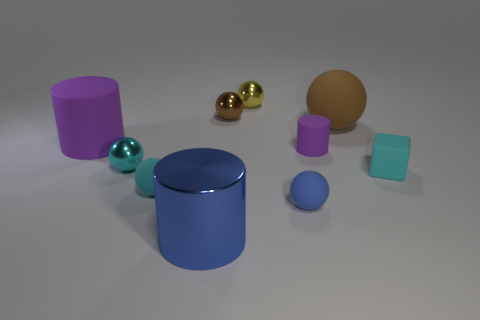What is the size of the cyan shiny ball?
Provide a succinct answer. Small. There is a cylinder that is to the right of the brown shiny object; is it the same color as the large shiny cylinder?
Give a very brief answer. No. Is the number of tiny balls behind the large blue object greater than the number of purple matte objects that are in front of the small matte cylinder?
Keep it short and to the point. Yes. Are there more green objects than brown rubber spheres?
Provide a short and direct response. No. There is a matte thing that is on the left side of the metallic cylinder and in front of the small purple thing; what is its size?
Give a very brief answer. Small. The big purple thing has what shape?
Make the answer very short. Cylinder. Are there any other things that have the same size as the blue metallic object?
Provide a succinct answer. Yes. Is the number of big brown rubber spheres that are right of the cyan cube greater than the number of tiny cyan shiny things?
Offer a terse response. No. The tiny cyan thing that is right of the large cylinder in front of the small matte thing that is behind the tiny cyan block is what shape?
Keep it short and to the point. Cube. There is a cylinder that is in front of the rubber cube; does it have the same size as the big brown matte object?
Ensure brevity in your answer.  Yes. 